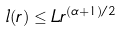<formula> <loc_0><loc_0><loc_500><loc_500>l ( r ) \leq L r ^ { ( \alpha + 1 ) / 2 }</formula> 